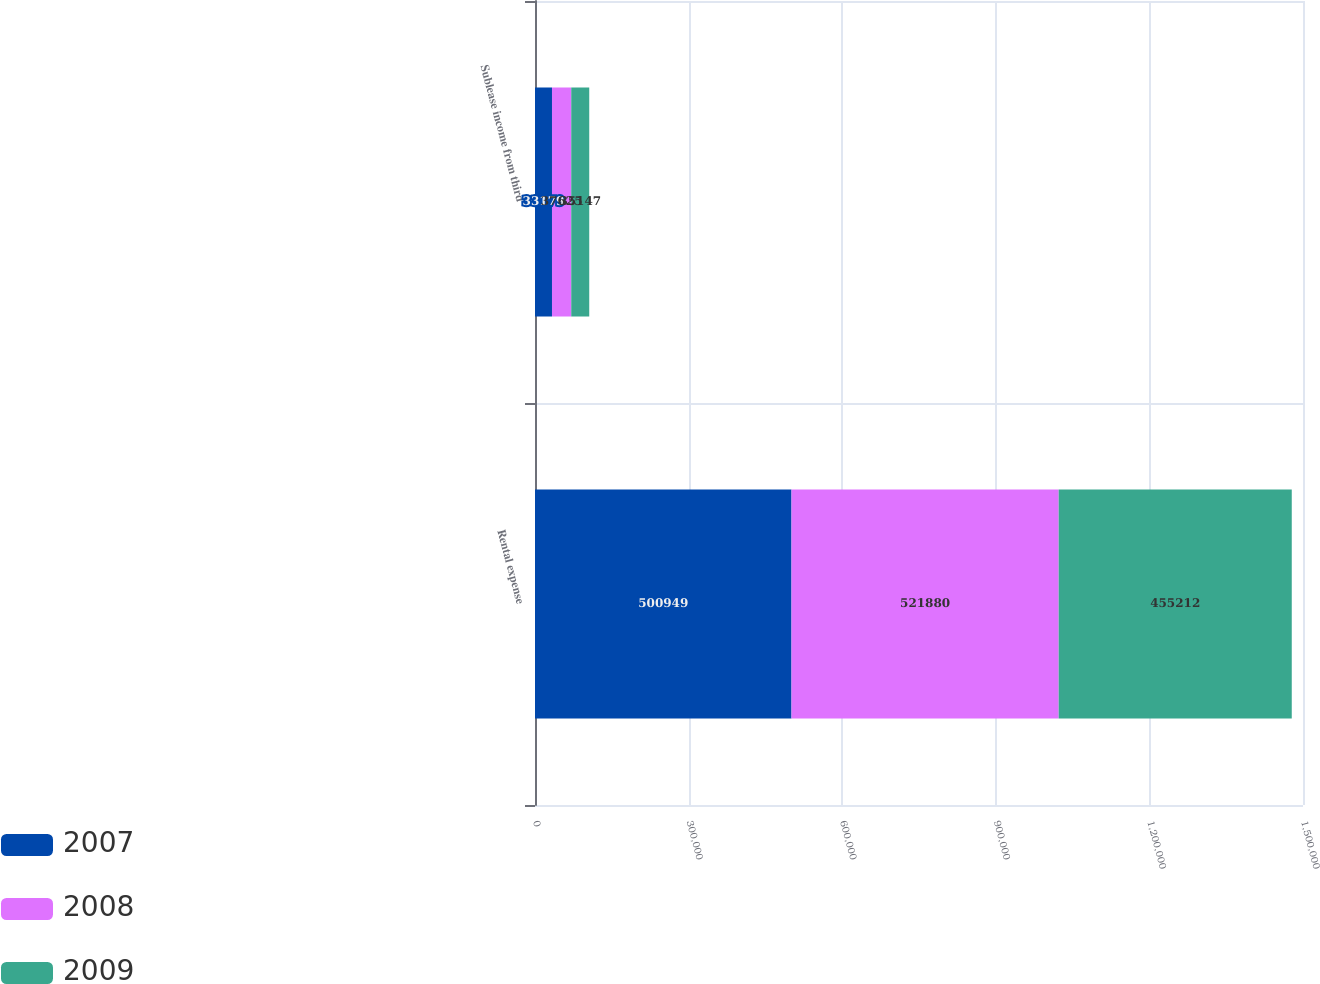Convert chart to OTSL. <chart><loc_0><loc_0><loc_500><loc_500><stacked_bar_chart><ecel><fcel>Rental expense<fcel>Sublease income from third<nl><fcel>2007<fcel>500949<fcel>33179<nl><fcel>2008<fcel>521880<fcel>37625<nl><fcel>2009<fcel>455212<fcel>35147<nl></chart> 